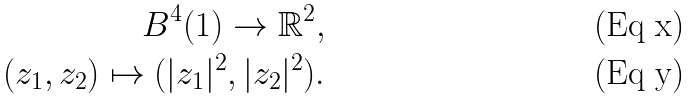Convert formula to latex. <formula><loc_0><loc_0><loc_500><loc_500>B ^ { 4 } ( 1 ) \rightarrow \mathbb { R } ^ { 2 } , \\ ( z _ { 1 } , z _ { 2 } ) \mapsto ( | z _ { 1 } | ^ { 2 } , | z _ { 2 } | ^ { 2 } ) .</formula> 